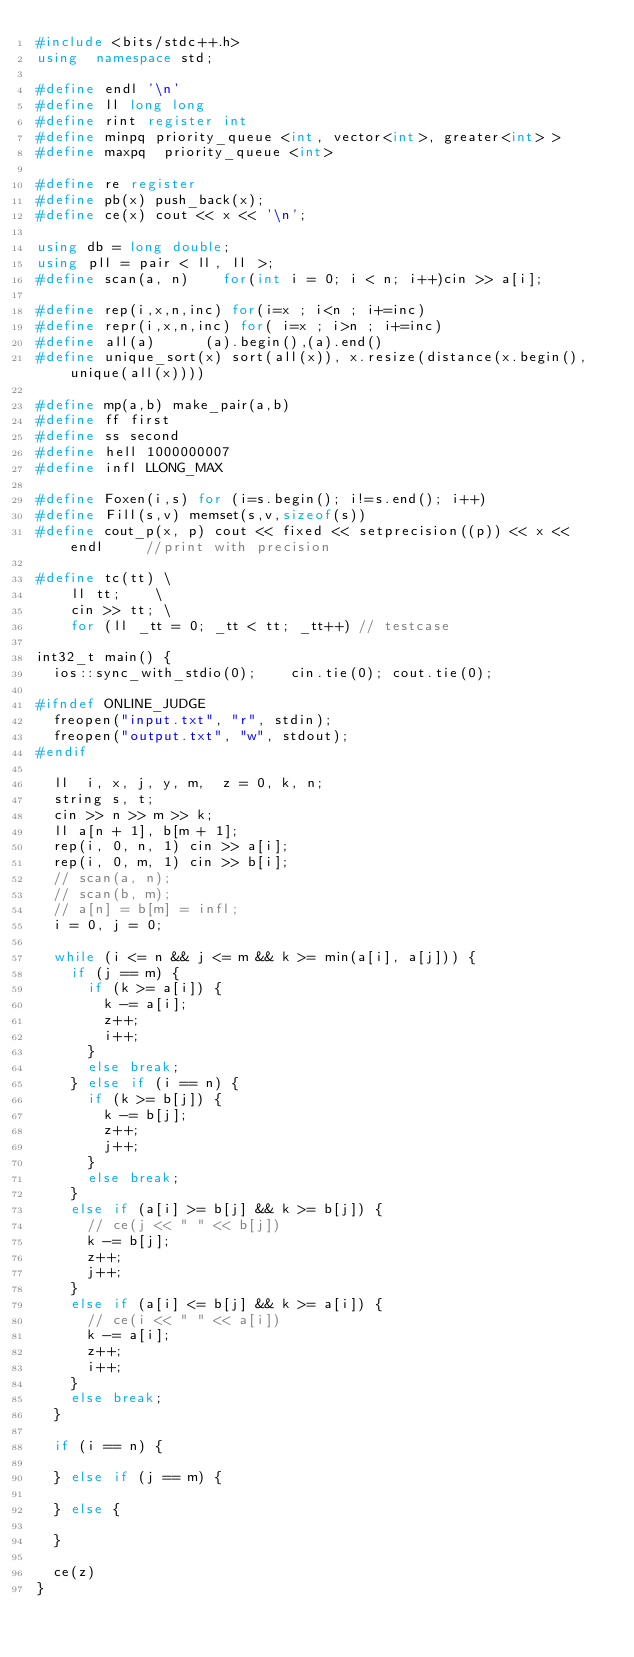Convert code to text. <code><loc_0><loc_0><loc_500><loc_500><_C++_>#include <bits/stdc++.h>
using  namespace std;

#define endl '\n'
#define ll long long
#define rint register int
#define minpq priority_queue <int, vector<int>, greater<int> >
#define maxpq  priority_queue <int>

#define re register
#define pb(x) push_back(x);
#define ce(x) cout << x << '\n';

using db = long double;
using pll = pair < ll, ll >;
#define scan(a, n) 		for(int i = 0; i < n; i++)cin >> a[i];

#define rep(i,x,n,inc) for(i=x ; i<n ; i+=inc)
#define repr(i,x,n,inc) for( i=x ; i>n ; i+=inc)
#define all(a)      (a).begin(),(a).end()
#define unique_sort(x) sort(all(x)), x.resize(distance(x.begin(), unique(all(x))))

#define mp(a,b) make_pair(a,b)
#define ff first
#define ss second
#define hell 1000000007
#define infl LLONG_MAX

#define Foxen(i,s) for (i=s.begin(); i!=s.end(); i++)
#define Fill(s,v) memset(s,v,sizeof(s))
#define cout_p(x, p) cout << fixed << setprecision((p)) << x << endl     //print with precision

#define tc(tt) \
    ll tt;    \
    cin >> tt; \
    for (ll _tt = 0; _tt < tt; _tt++) // testcase 

int32_t main() {
	ios::sync_with_stdio(0); 		cin.tie(0); cout.tie(0);

#ifndef ONLINE_JUDGE
	freopen("input.txt", "r", stdin);
	freopen("output.txt", "w", stdout);
#endif

	ll  i, x, j, y, m,	z = 0, k, n;
	string s, t;
	cin >> n >> m >> k;
	ll a[n + 1], b[m + 1];
	rep(i, 0, n, 1)	cin >> a[i];
	rep(i, 0, m, 1)	cin >> b[i];
	// scan(a, n);
	// scan(b, m);
	// a[n] = b[m] = infl;
	i = 0, j = 0;

	while (i <= n && j <= m && k >= min(a[i], a[j])) {
		if (j == m) {
			if (k >= a[i]) {
				k -= a[i];
				z++;
				i++;
			}
			else break;
		} else if (i == n) {
			if (k >= b[j]) {
				k -= b[j];
				z++;
				j++;
			}
			else break;
		}
		else if (a[i] >= b[j] && k >= b[j])	{
			// ce(j << " " << b[j])
			k -= b[j];
			z++;
			j++;
		}
		else if (a[i] <= b[j] && k >= a[i]) {
			// ce(i << " " << a[i])
			k -= a[i];
			z++;
			i++;
		}
		else break;
	}

	if (i == n) {

	} else if (j == m) {

	} else {

	}

	ce(z)
}
</code> 